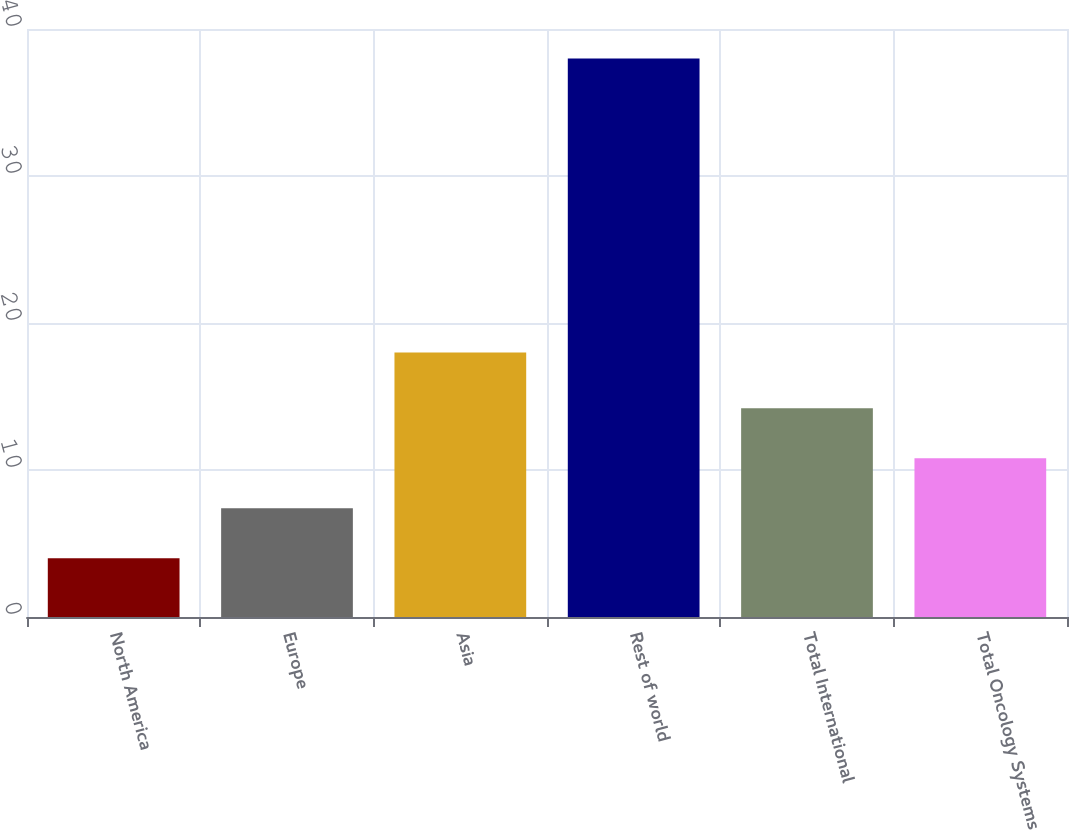Convert chart to OTSL. <chart><loc_0><loc_0><loc_500><loc_500><bar_chart><fcel>North America<fcel>Europe<fcel>Asia<fcel>Rest of world<fcel>Total International<fcel>Total Oncology Systems<nl><fcel>4<fcel>7.4<fcel>18<fcel>38<fcel>14.2<fcel>10.8<nl></chart> 